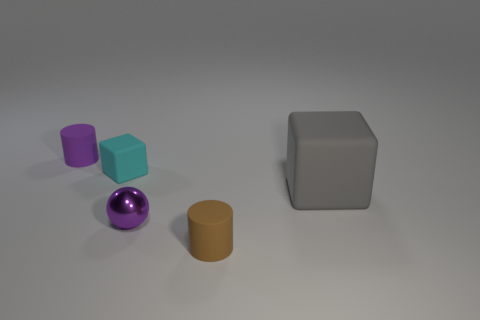How many objects are cylinders that are in front of the large thing or cylinders that are behind the tiny purple shiny object?
Offer a terse response. 2. The rubber thing to the right of the tiny thing that is on the right side of the tiny purple shiny object is what shape?
Your response must be concise. Cube. Are there any small cyan objects that have the same material as the tiny brown cylinder?
Offer a terse response. Yes. There is a small thing that is the same shape as the big object; what is its color?
Provide a succinct answer. Cyan. Is the number of gray cubes that are in front of the metallic object less than the number of small purple cylinders that are in front of the brown rubber cylinder?
Provide a succinct answer. No. What number of other objects are the same shape as the purple metal thing?
Provide a succinct answer. 0. Is the number of purple metal things that are on the right side of the metallic object less than the number of small purple metal things?
Offer a terse response. Yes. There is a purple thing that is behind the tiny ball; what is it made of?
Offer a very short reply. Rubber. What number of other objects are there of the same size as the purple metal ball?
Offer a terse response. 3. Is the number of small green things less than the number of small cyan matte objects?
Your response must be concise. Yes. 